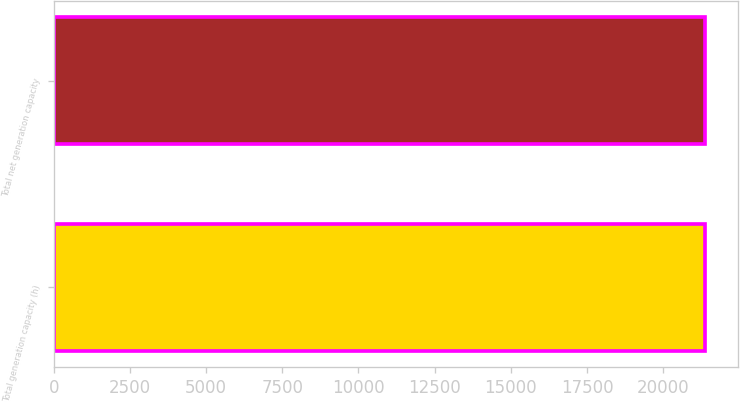Convert chart to OTSL. <chart><loc_0><loc_0><loc_500><loc_500><bar_chart><fcel>Total generation capacity (h)<fcel>Total net generation capacity<nl><fcel>21386<fcel>21386.1<nl></chart> 